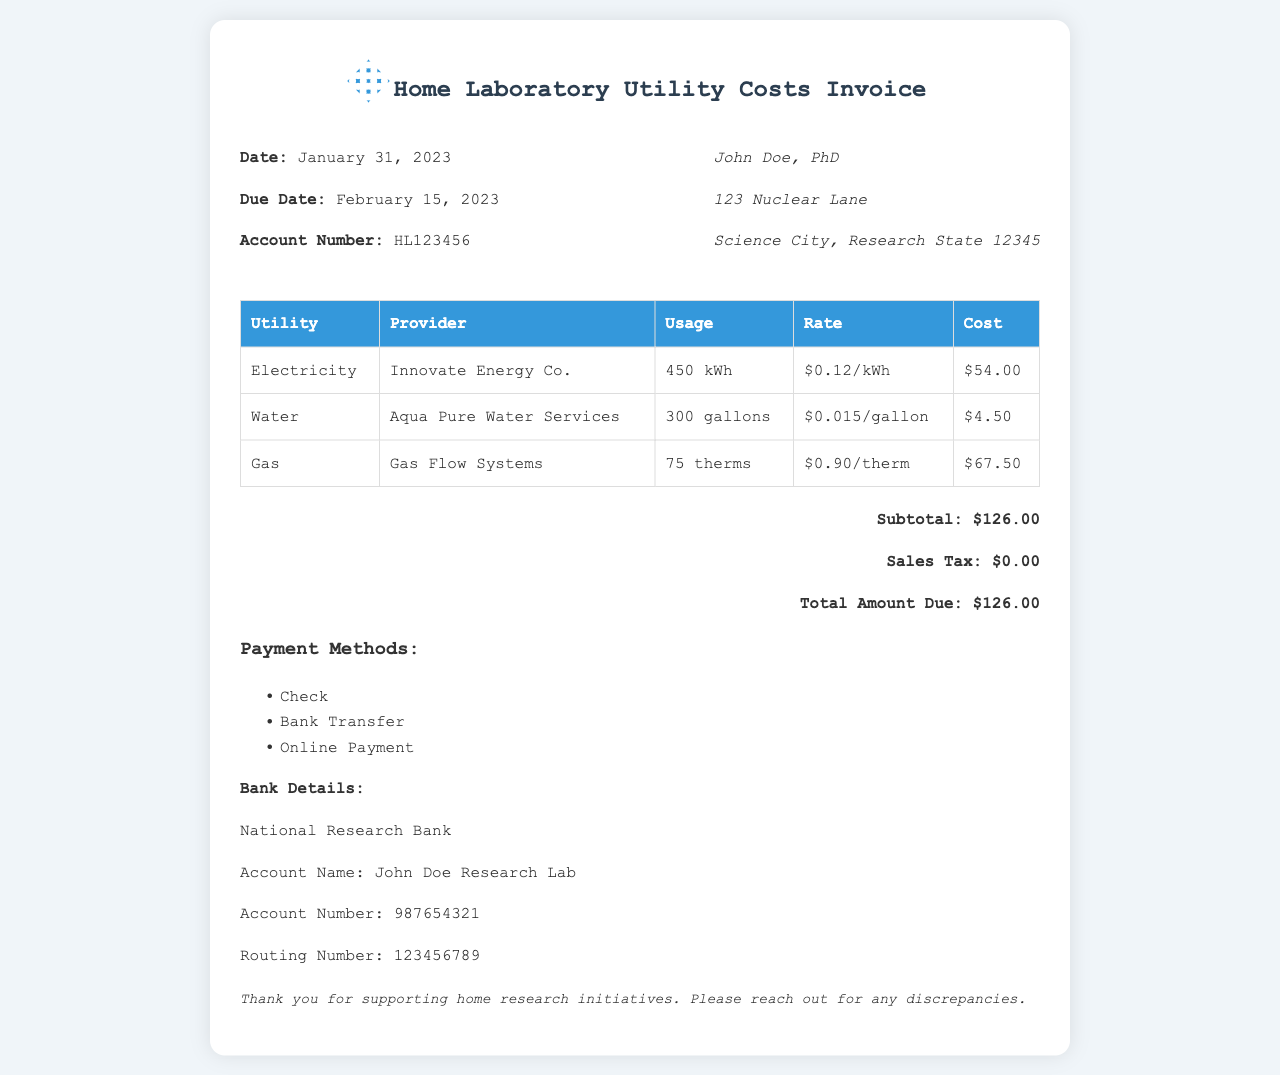what is the total amount due? The total amount due is the overall cost calculated in the invoice, which is $126.00.
Answer: $126.00 who is the provider of electricity? The provider of electricity listed in the invoice is Innovate Energy Co.
Answer: Innovate Energy Co how many gallons of water were used? The invoice specifies the water usage as 300 gallons.
Answer: 300 gallons what is the due date for payment? The due date for payment is provided in the invoice as February 15, 2023.
Answer: February 15, 2023 how much does gas cost per therm? The document states that the gas cost is $0.90 per therm.
Answer: $0.90/therm what is the subtotal before tax? The subtotal before tax is provided in the invoice as $126.00.
Answer: $126.00 what payment methods are accepted? The invoice lists accepted payment methods including Check, Bank Transfer, and Online Payment.
Answer: Check, Bank Transfer, Online Payment who is the account holder for bank details? The account holder's name for the bank details is stated as John Doe Research Lab.
Answer: John Doe Research Lab how many therms of gas were used? The usage of gas is specified in the invoice as 75 therms.
Answer: 75 therms 